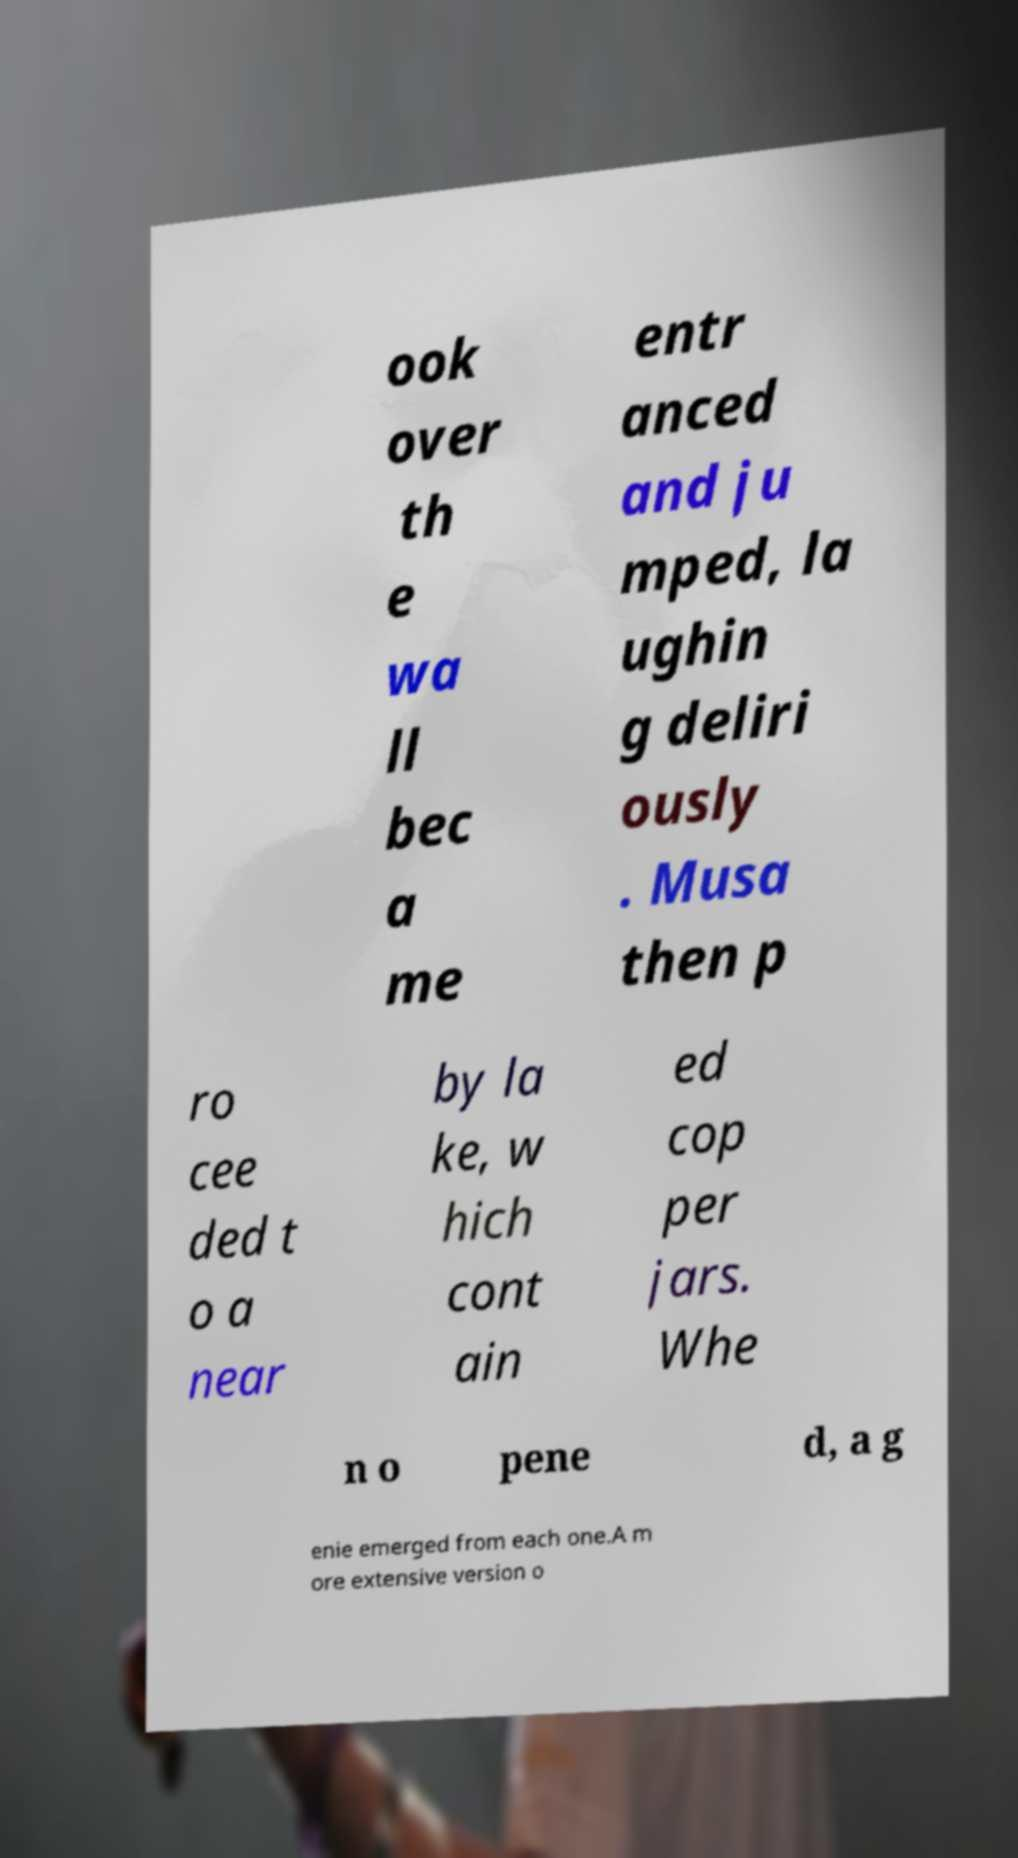Please read and relay the text visible in this image. What does it say? ook over th e wa ll bec a me entr anced and ju mped, la ughin g deliri ously . Musa then p ro cee ded t o a near by la ke, w hich cont ain ed cop per jars. Whe n o pene d, a g enie emerged from each one.A m ore extensive version o 